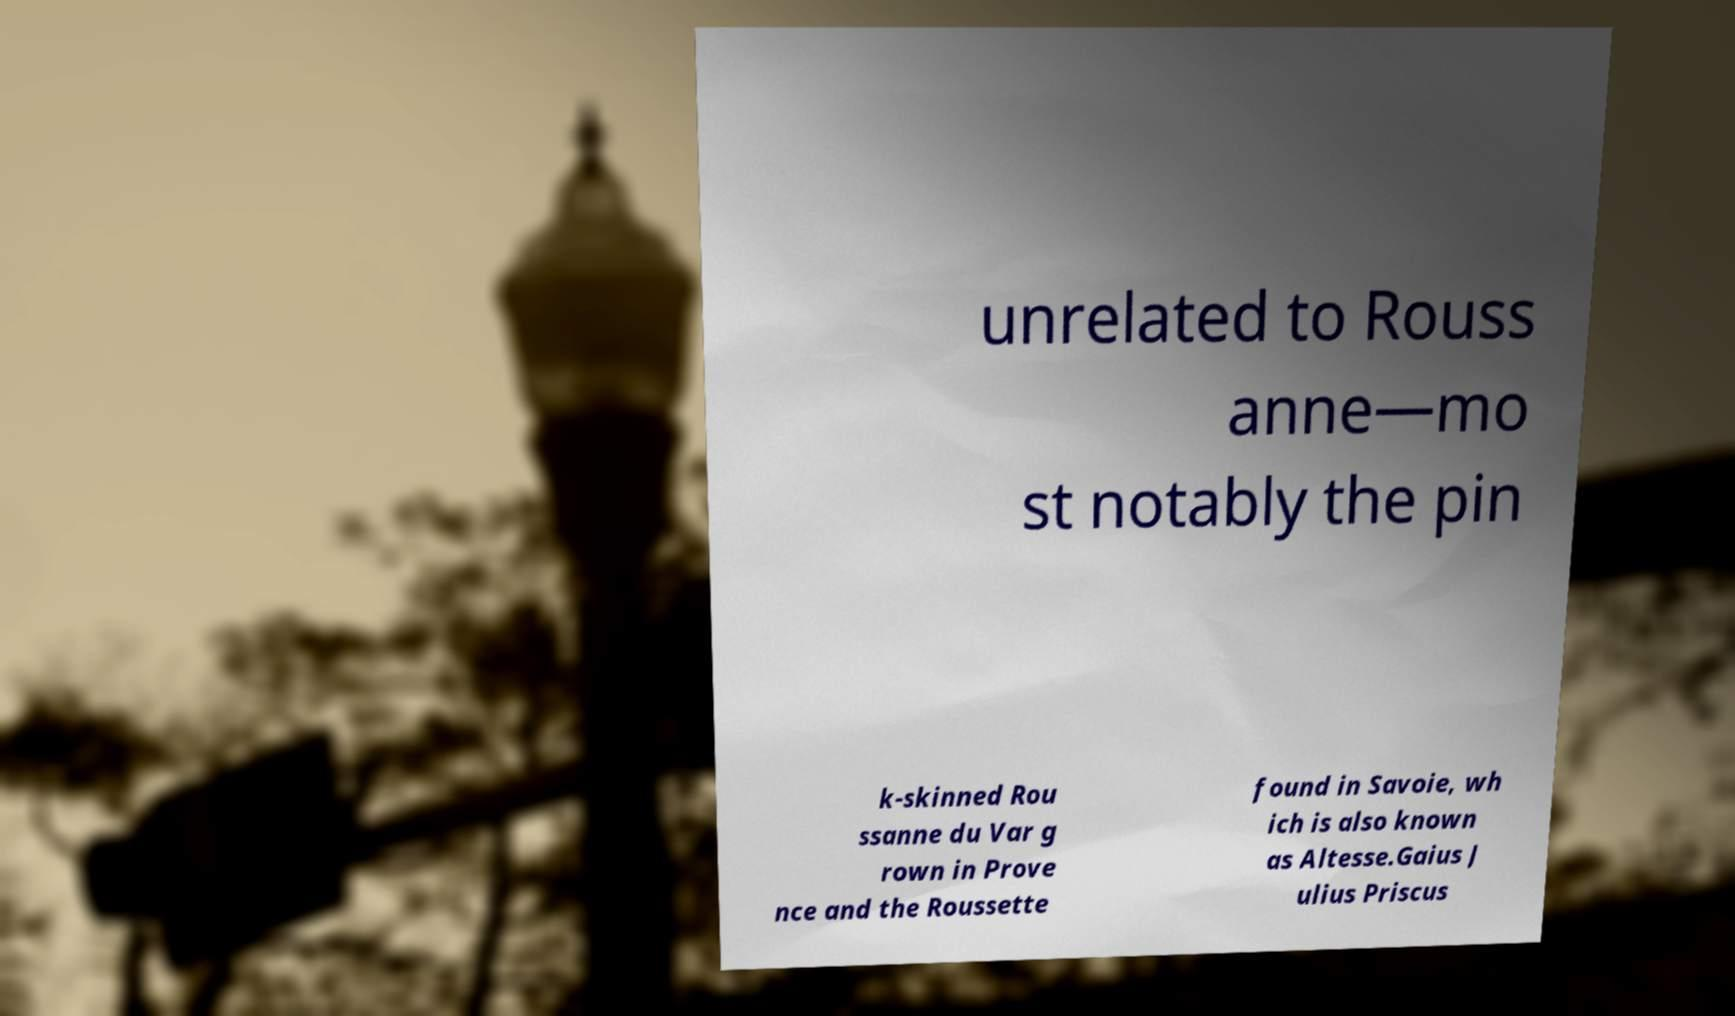Can you read and provide the text displayed in the image?This photo seems to have some interesting text. Can you extract and type it out for me? unrelated to Rouss anne—mo st notably the pin k-skinned Rou ssanne du Var g rown in Prove nce and the Roussette found in Savoie, wh ich is also known as Altesse.Gaius J ulius Priscus 